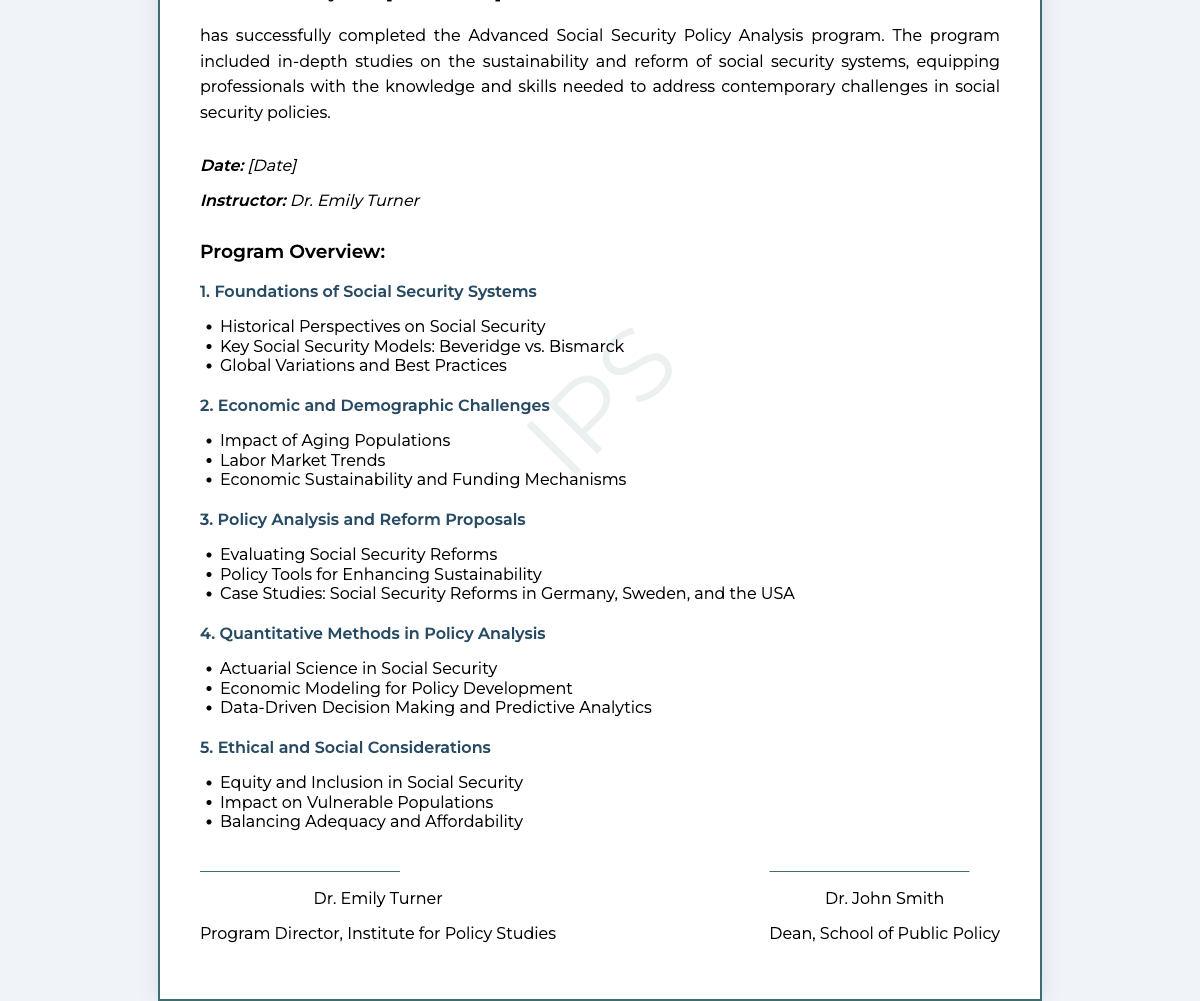What is the title of the program? The title of the program is clearly stated in the document header, which reads "Advanced Social Security Policy Analysis."
Answer: Advanced Social Security Policy Analysis Who is the certificate presented to? The certificate contains a placeholder indicating the recipient's name, which would typically be filled in with the actual person's name.
Answer: [Your Name] What date is listed on the certificate? The document includes a placeholder for the date of completion, indicating when the certificate was issued.
Answer: [Date] Who is the instructor for the program? The instructor's name is specifically mentioned in the document, indicating who taught the program.
Answer: Dr. Emily Turner How many modules are included in the program? The document lists five distinct modules within the program overview section.
Answer: 5 What is the focus of the first module? The first module is titled "Foundations of Social Security Systems," indicating its primary focus area.
Answer: Foundations of Social Security Systems What aspect of social security is addressed in the second module? The second module addresses challenges related to demographics and economics, as specified in its title and content.
Answer: Economic and Demographic Challenges What type of analysis is emphasized in the fourth module? The fourth module emphasizes quantitative methods specifically designed for policy analysis, according to the content outlined.
Answer: Quantitative Methods in Policy Analysis What is a key ethical consideration discussed in the fifth module? The fifth module specifically addresses "Equity and Inclusion in Social Security," highlighting an important ethical consideration.
Answer: Equity and Inclusion in Social Security 